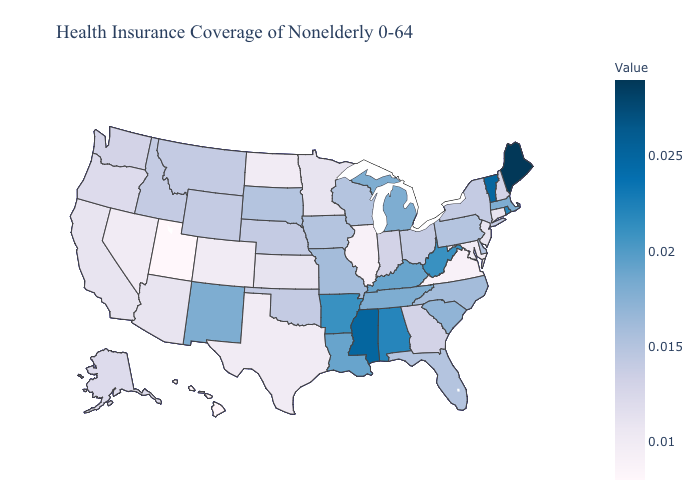Does Massachusetts have the highest value in the Northeast?
Be succinct. No. Among the states that border Kentucky , does Virginia have the lowest value?
Concise answer only. Yes. Is the legend a continuous bar?
Keep it brief. Yes. Among the states that border Oregon , which have the lowest value?
Be succinct. Nevada. Which states have the highest value in the USA?
Concise answer only. Maine. Which states have the lowest value in the South?
Quick response, please. Virginia. 